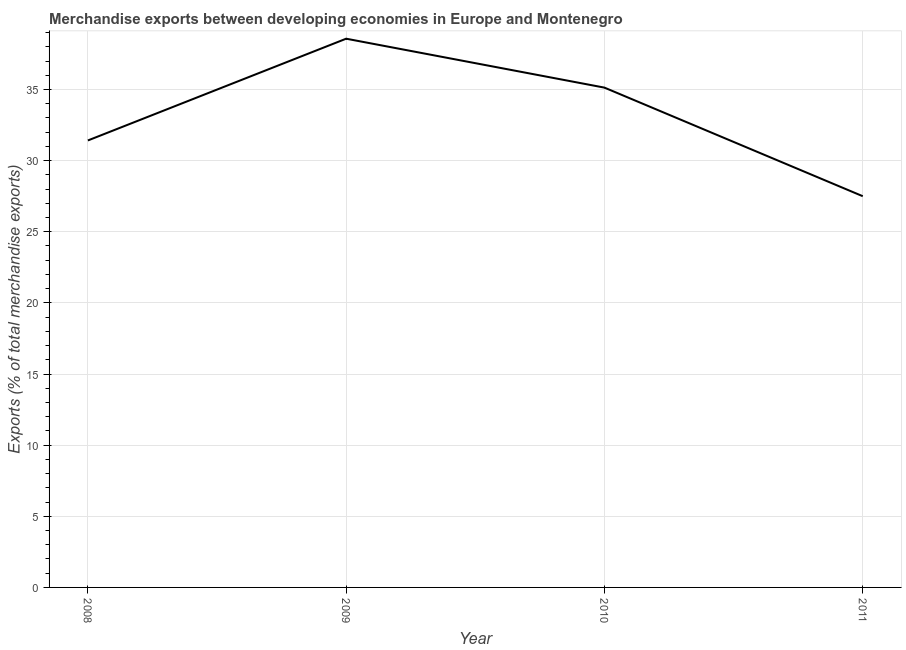What is the merchandise exports in 2011?
Your answer should be very brief. 27.5. Across all years, what is the maximum merchandise exports?
Ensure brevity in your answer.  38.57. Across all years, what is the minimum merchandise exports?
Provide a succinct answer. 27.5. What is the sum of the merchandise exports?
Make the answer very short. 132.61. What is the difference between the merchandise exports in 2010 and 2011?
Your answer should be very brief. 7.63. What is the average merchandise exports per year?
Offer a terse response. 33.15. What is the median merchandise exports?
Provide a short and direct response. 33.27. In how many years, is the merchandise exports greater than 28 %?
Provide a succinct answer. 3. Do a majority of the years between 2010 and 2009 (inclusive) have merchandise exports greater than 32 %?
Offer a very short reply. No. What is the ratio of the merchandise exports in 2009 to that in 2010?
Make the answer very short. 1.1. Is the merchandise exports in 2008 less than that in 2011?
Offer a very short reply. No. Is the difference between the merchandise exports in 2008 and 2011 greater than the difference between any two years?
Offer a terse response. No. What is the difference between the highest and the second highest merchandise exports?
Keep it short and to the point. 3.44. What is the difference between the highest and the lowest merchandise exports?
Ensure brevity in your answer.  11.07. Does the merchandise exports monotonically increase over the years?
Your answer should be very brief. No. What is the difference between two consecutive major ticks on the Y-axis?
Provide a short and direct response. 5. Does the graph contain any zero values?
Give a very brief answer. No. What is the title of the graph?
Ensure brevity in your answer.  Merchandise exports between developing economies in Europe and Montenegro. What is the label or title of the Y-axis?
Offer a terse response. Exports (% of total merchandise exports). What is the Exports (% of total merchandise exports) of 2008?
Provide a succinct answer. 31.42. What is the Exports (% of total merchandise exports) of 2009?
Offer a terse response. 38.57. What is the Exports (% of total merchandise exports) of 2010?
Offer a terse response. 35.13. What is the Exports (% of total merchandise exports) in 2011?
Offer a terse response. 27.5. What is the difference between the Exports (% of total merchandise exports) in 2008 and 2009?
Offer a very short reply. -7.15. What is the difference between the Exports (% of total merchandise exports) in 2008 and 2010?
Ensure brevity in your answer.  -3.71. What is the difference between the Exports (% of total merchandise exports) in 2008 and 2011?
Your answer should be very brief. 3.92. What is the difference between the Exports (% of total merchandise exports) in 2009 and 2010?
Your answer should be very brief. 3.44. What is the difference between the Exports (% of total merchandise exports) in 2009 and 2011?
Your answer should be very brief. 11.07. What is the difference between the Exports (% of total merchandise exports) in 2010 and 2011?
Provide a short and direct response. 7.63. What is the ratio of the Exports (% of total merchandise exports) in 2008 to that in 2009?
Give a very brief answer. 0.81. What is the ratio of the Exports (% of total merchandise exports) in 2008 to that in 2010?
Provide a succinct answer. 0.89. What is the ratio of the Exports (% of total merchandise exports) in 2008 to that in 2011?
Make the answer very short. 1.14. What is the ratio of the Exports (% of total merchandise exports) in 2009 to that in 2010?
Provide a succinct answer. 1.1. What is the ratio of the Exports (% of total merchandise exports) in 2009 to that in 2011?
Your response must be concise. 1.4. What is the ratio of the Exports (% of total merchandise exports) in 2010 to that in 2011?
Offer a terse response. 1.28. 